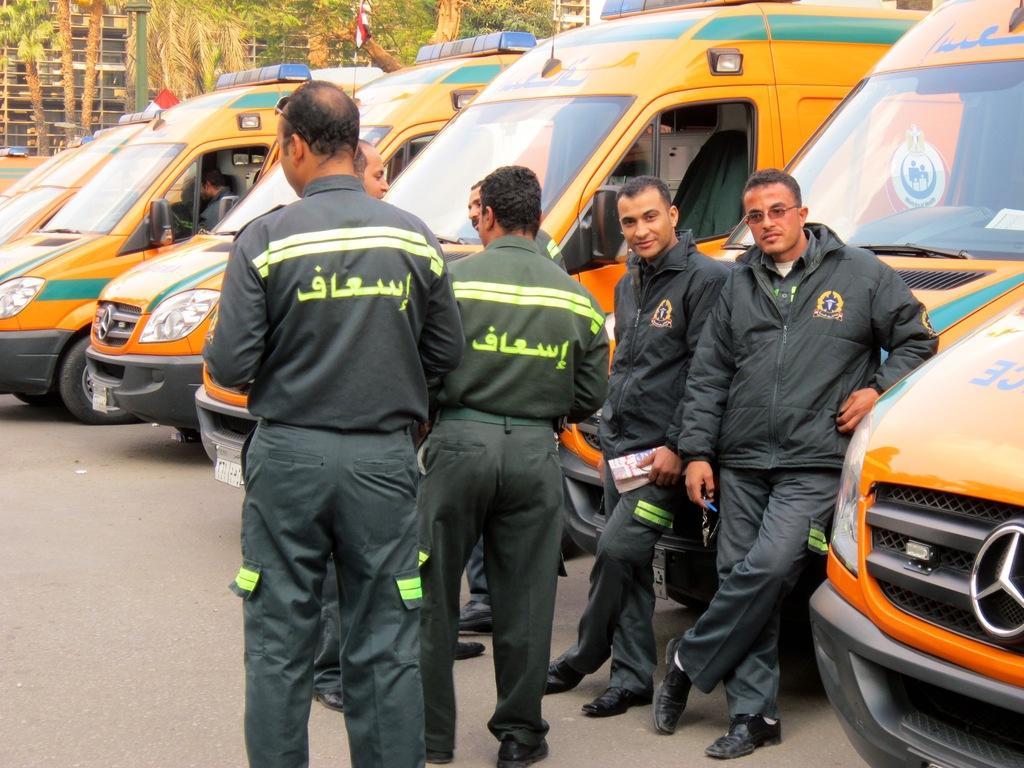Please provide a concise description of this image. In this image there are group of person standing in the center. On the right side there are vehicles which are yellow in colour and some text written on it. In the background there are trees and there is a pole. 